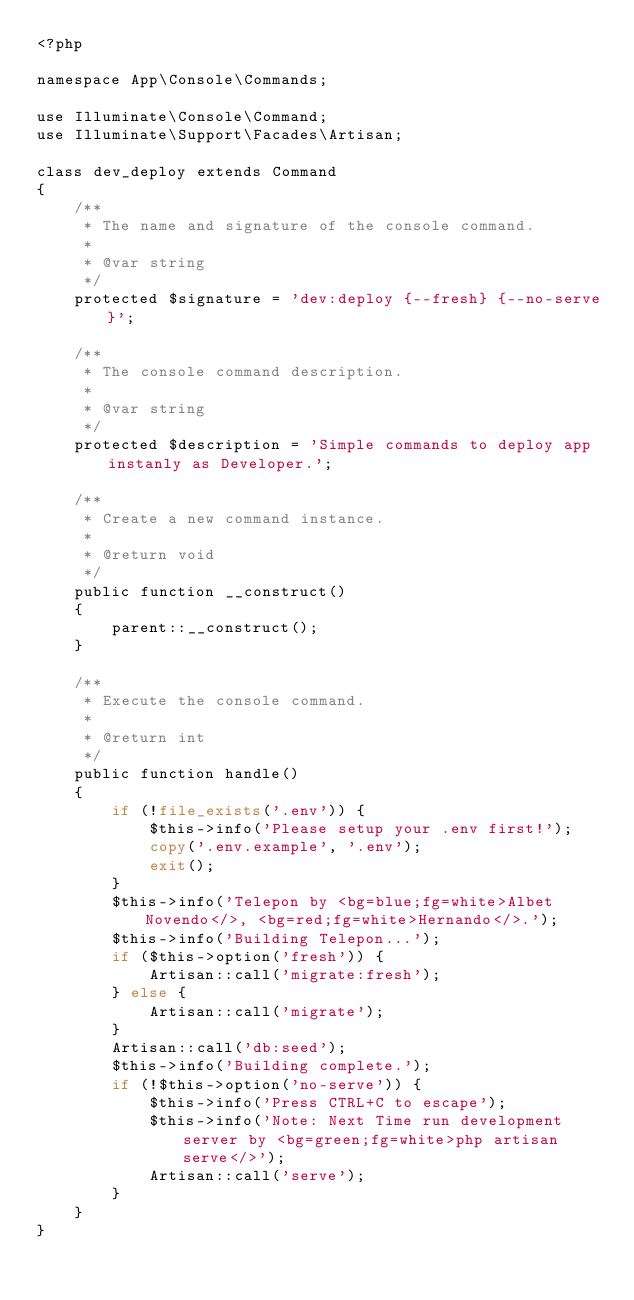Convert code to text. <code><loc_0><loc_0><loc_500><loc_500><_PHP_><?php

namespace App\Console\Commands;

use Illuminate\Console\Command;
use Illuminate\Support\Facades\Artisan;

class dev_deploy extends Command
{
    /**
     * The name and signature of the console command.
     *
     * @var string
     */
    protected $signature = 'dev:deploy {--fresh} {--no-serve}';

    /**
     * The console command description.
     *
     * @var string
     */
    protected $description = 'Simple commands to deploy app instanly as Developer.';

    /**
     * Create a new command instance.
     *
     * @return void
     */
    public function __construct()
    {
        parent::__construct();
    }

    /**
     * Execute the console command.
     *
     * @return int
     */
    public function handle()
    {
        if (!file_exists('.env')) {
            $this->info('Please setup your .env first!');
            copy('.env.example', '.env');
            exit();
        }
        $this->info('Telepon by <bg=blue;fg=white>Albet Novendo</>, <bg=red;fg=white>Hernando</>.');
        $this->info('Building Telepon...');
        if ($this->option('fresh')) {
            Artisan::call('migrate:fresh');
        } else {
            Artisan::call('migrate');
        }
        Artisan::call('db:seed');
        $this->info('Building complete.');
        if (!$this->option('no-serve')) {
            $this->info('Press CTRL+C to escape');
            $this->info('Note: Next Time run development server by <bg=green;fg=white>php artisan serve</>');
            Artisan::call('serve');
        }
    }
}
</code> 